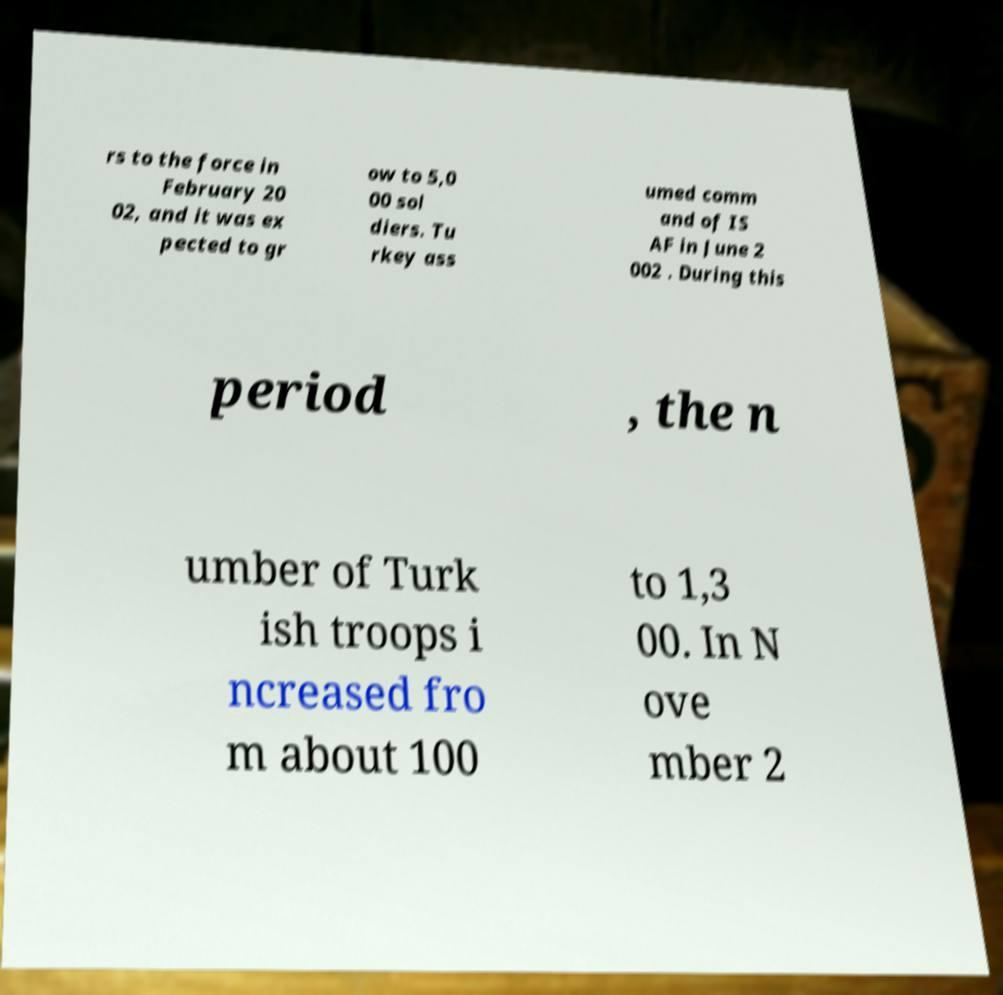Please read and relay the text visible in this image. What does it say? rs to the force in February 20 02, and it was ex pected to gr ow to 5,0 00 sol diers. Tu rkey ass umed comm and of IS AF in June 2 002 . During this period , the n umber of Turk ish troops i ncreased fro m about 100 to 1,3 00. In N ove mber 2 